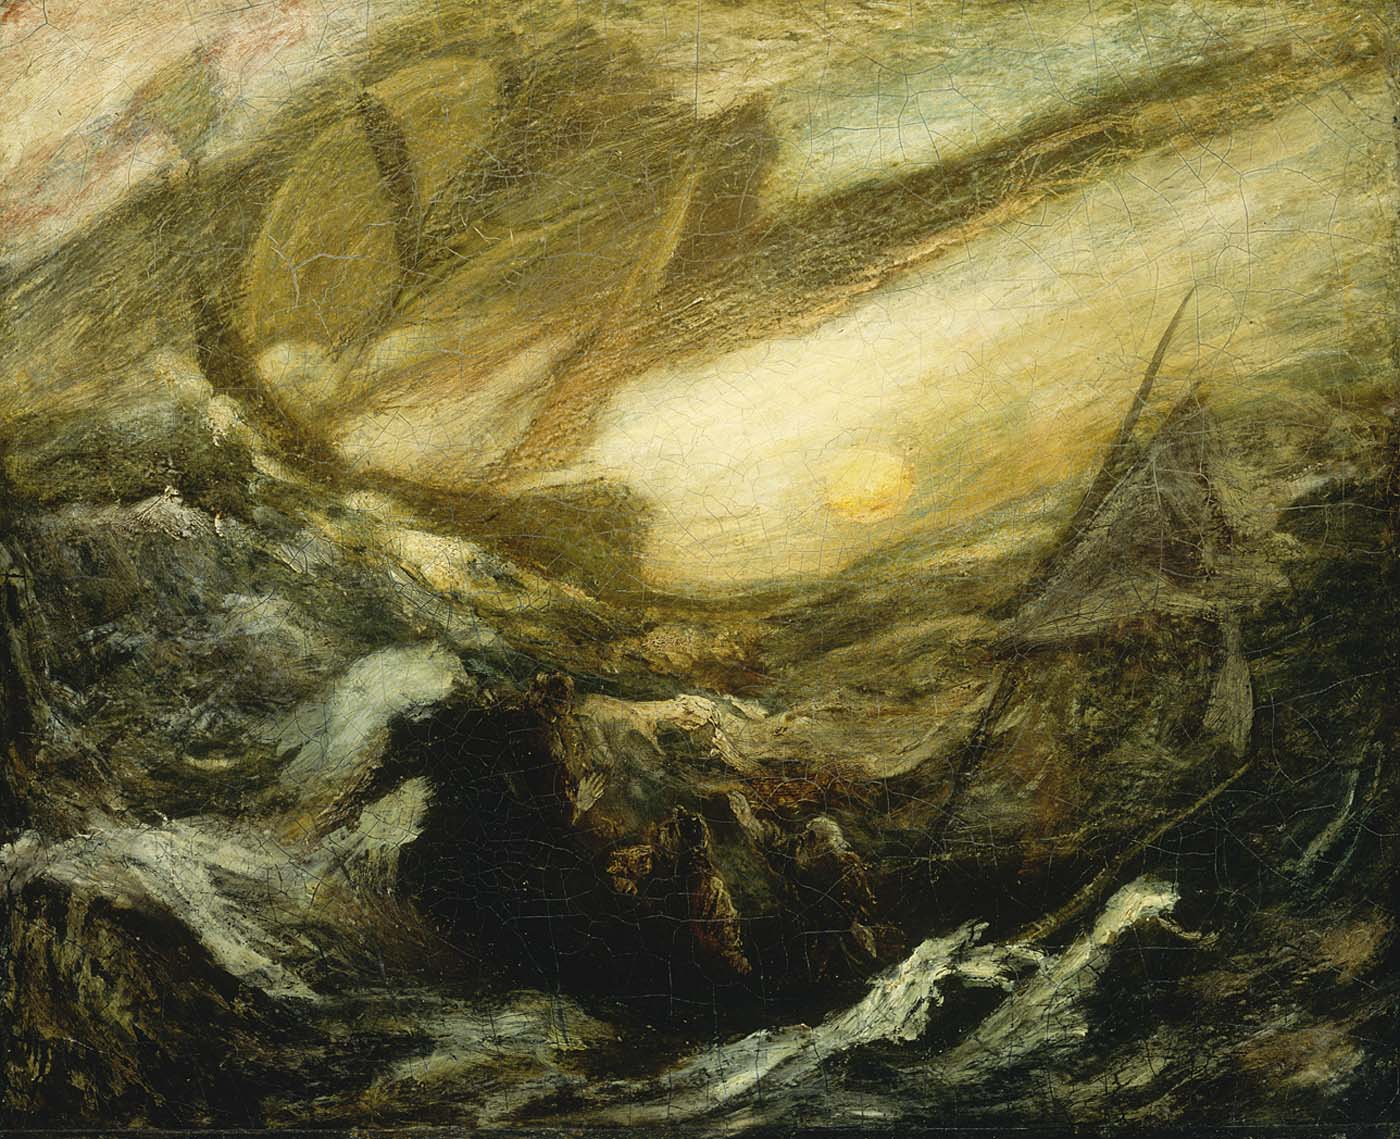Can you describe the mood that this painting evokes? This painting evokes a mood of intense drama and tension, intertwined with a sense of awe and mystery. The dark, swirling waves create an atmosphere of danger and chaos, while the presence of the bright sun adds an element of hope and transcendence. There's an underlying feeling of struggle and survival against the odds, as if capturing a moment of raw, unfiltered nature at its most powerful. It's a mood that makes one reflect on the untamable forces of the natural world and our place within it. 